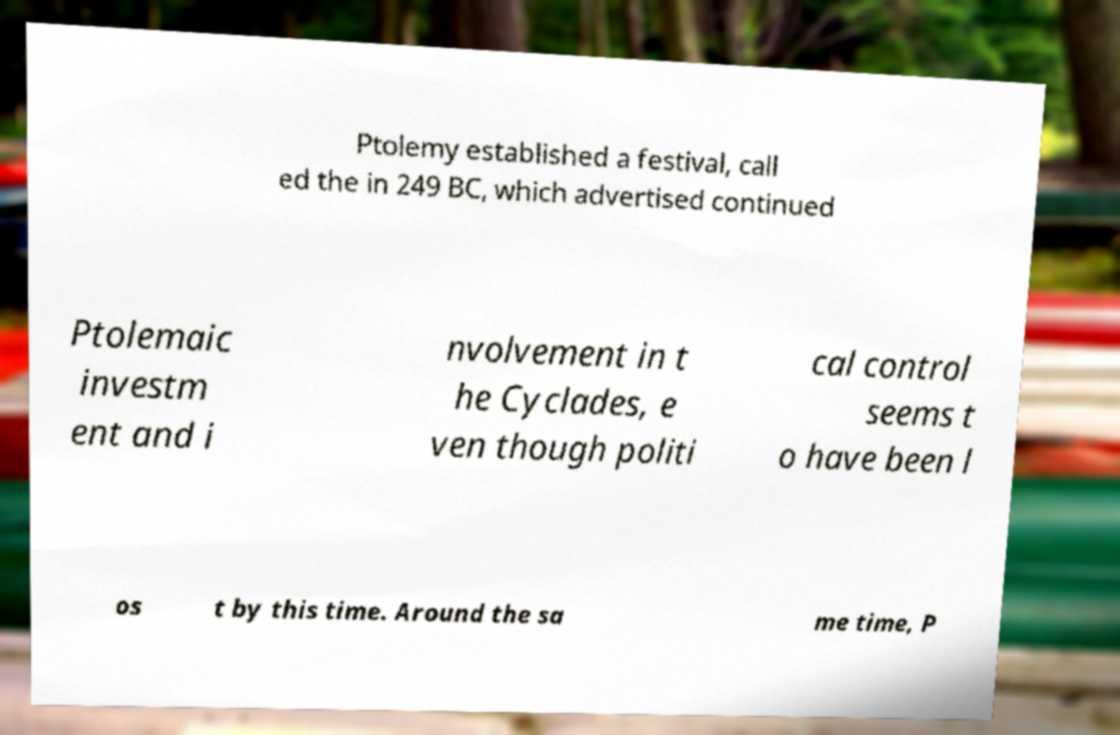Please identify and transcribe the text found in this image. Ptolemy established a festival, call ed the in 249 BC, which advertised continued Ptolemaic investm ent and i nvolvement in t he Cyclades, e ven though politi cal control seems t o have been l os t by this time. Around the sa me time, P 